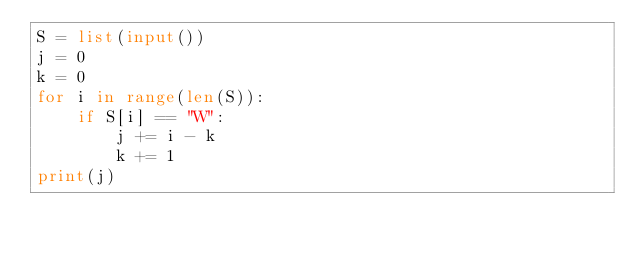Convert code to text. <code><loc_0><loc_0><loc_500><loc_500><_Python_>S = list(input())
j = 0
k = 0
for i in range(len(S)):
    if S[i] == "W":
        j += i - k
        k += 1
print(j)</code> 